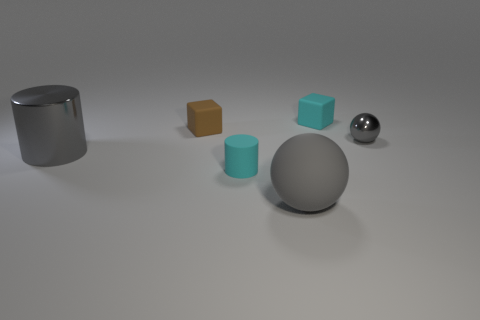Add 4 gray metallic spheres. How many objects exist? 10 Subtract all blocks. How many objects are left? 4 Add 4 large gray balls. How many large gray balls are left? 5 Add 4 tiny gray shiny objects. How many tiny gray shiny objects exist? 5 Subtract 0 cyan spheres. How many objects are left? 6 Subtract all gray rubber cylinders. Subtract all metallic things. How many objects are left? 4 